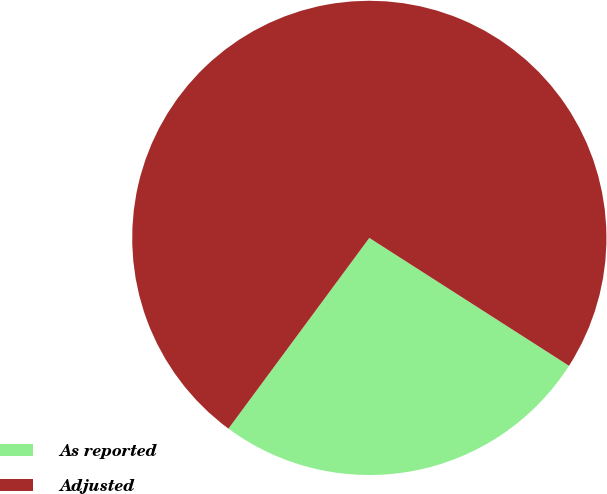<chart> <loc_0><loc_0><loc_500><loc_500><pie_chart><fcel>As reported<fcel>Adjusted<nl><fcel>26.06%<fcel>73.94%<nl></chart> 